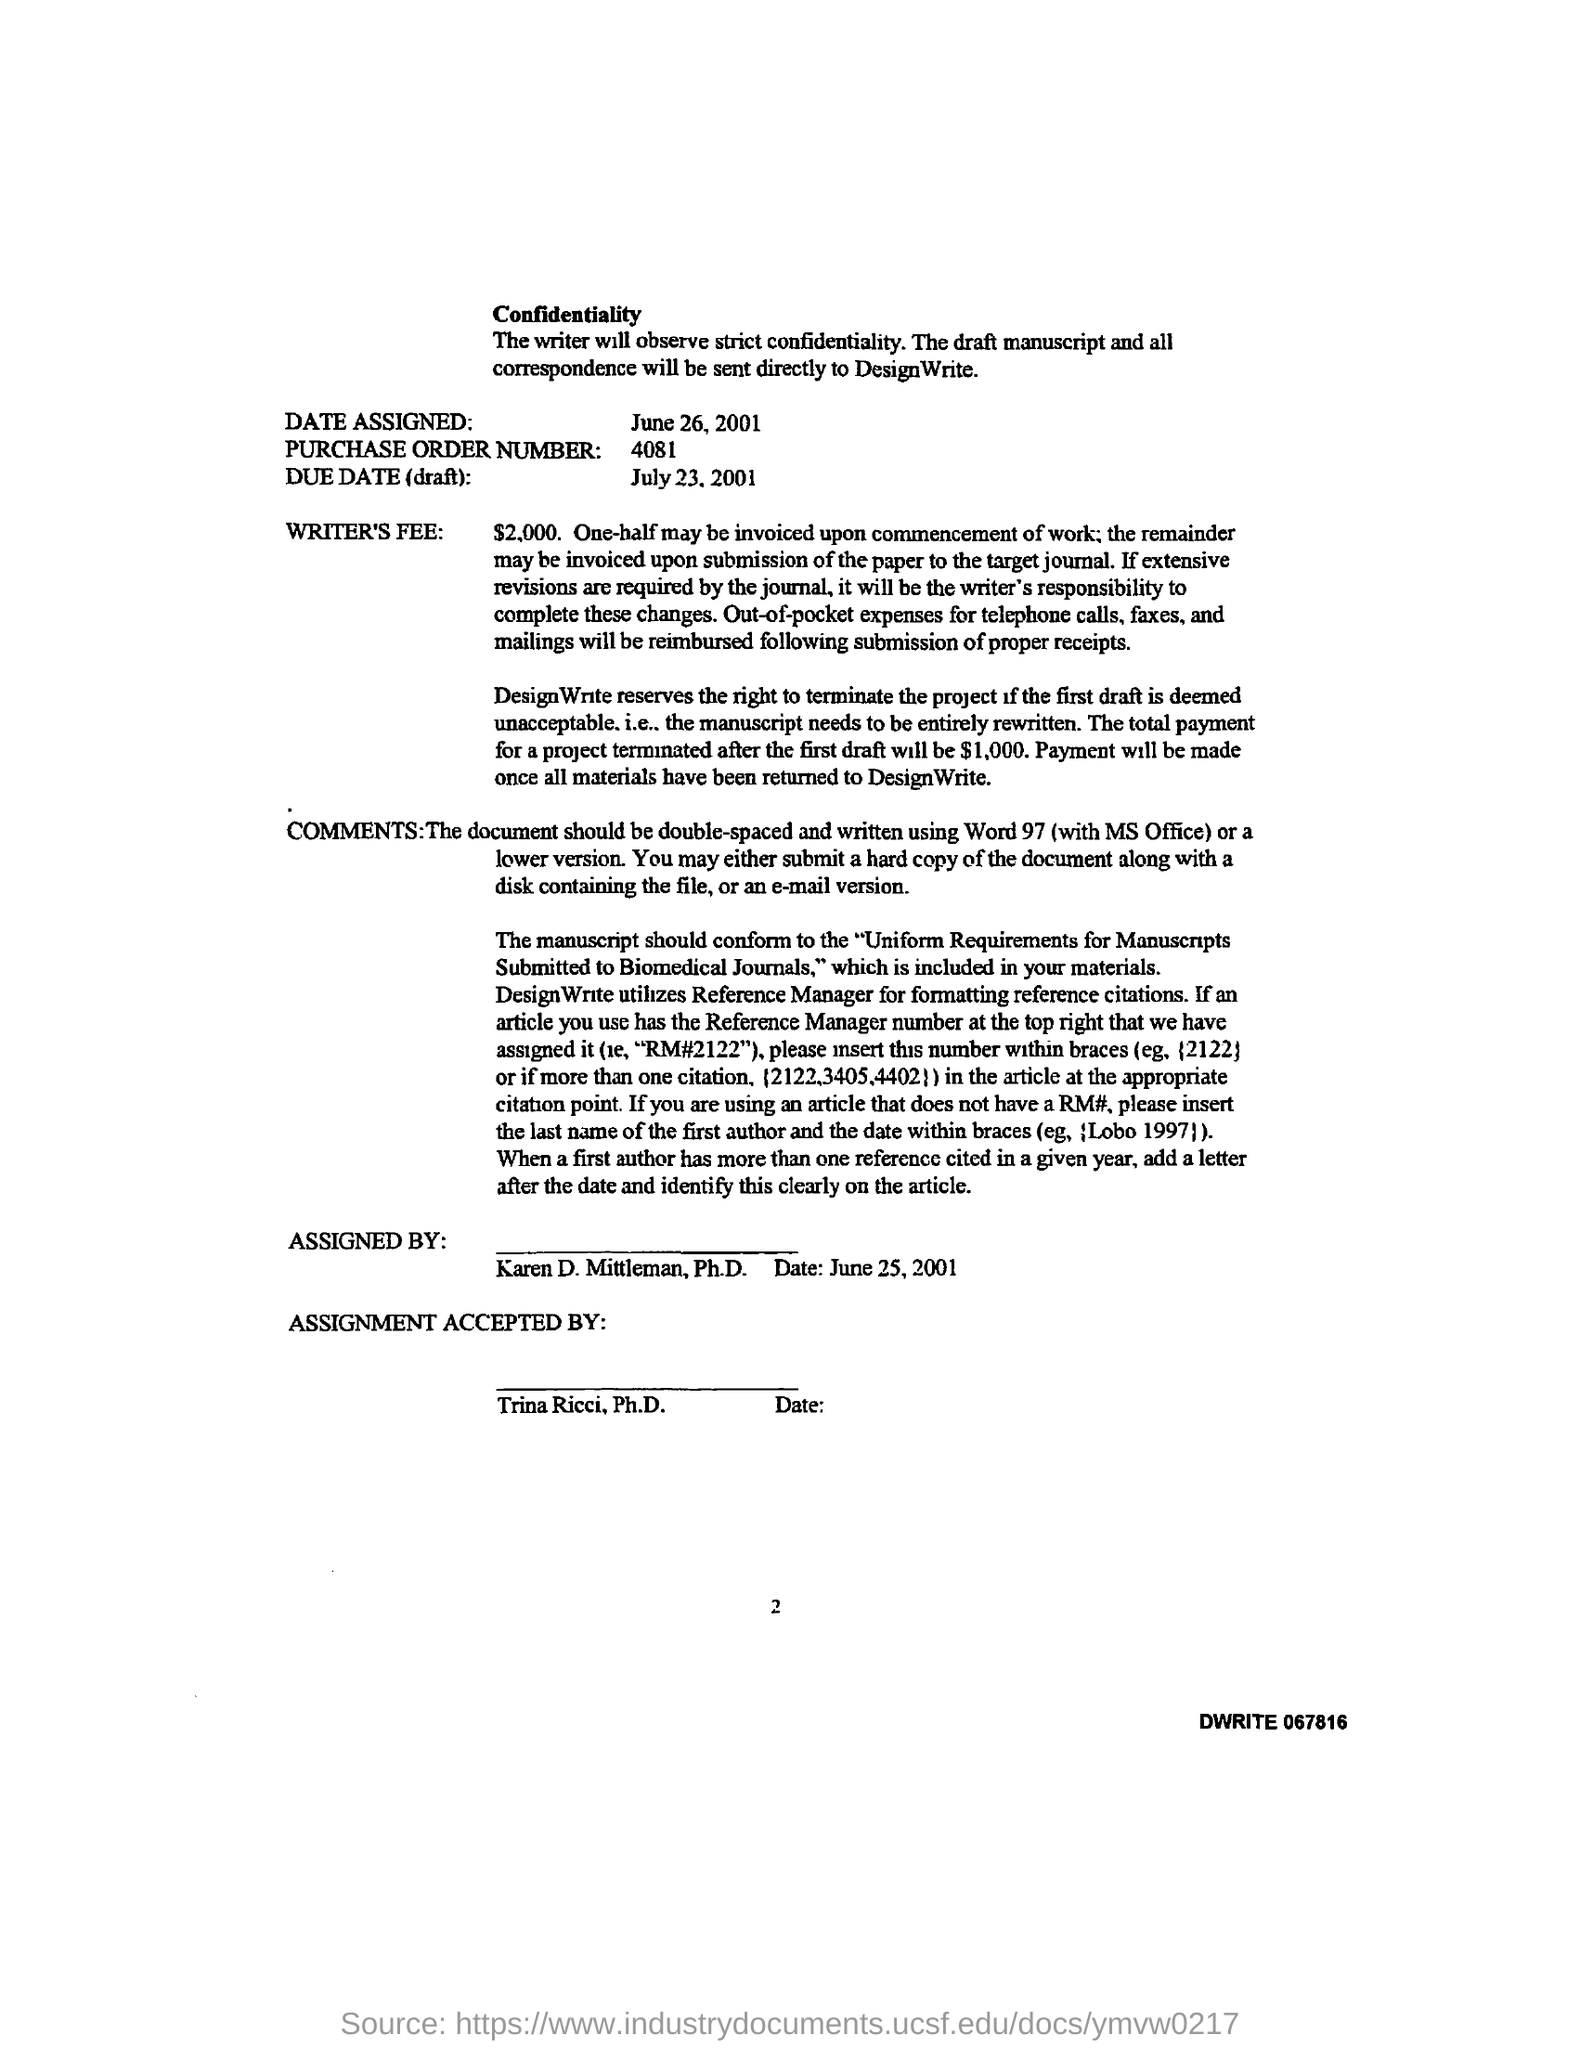Highlight a few significant elements in this photo. The purchased order number mentioned in the given letter is 4081. The assignment was accepted by Trina Ricci in the given letter. This letter was assigned by Karen D. Mittleman to [person/entity]. The total payment for a project terminated after the first draft is expected to be $1,000. The writer's fee mentioned in the given letter is $2,000. 